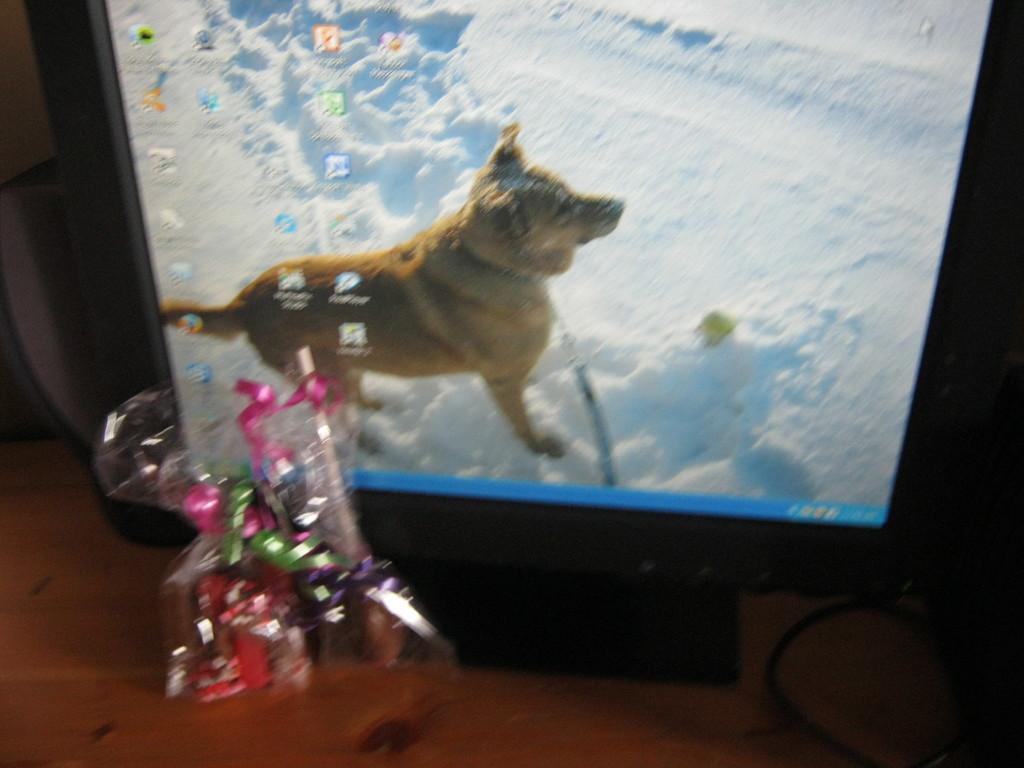How would you summarize this image in a sentence or two? This image is taken indoors. At the bottom of the image there is a table with a monitor and a few things on it. On the monitor screen there is a dog and there is a ground covered with snow. 